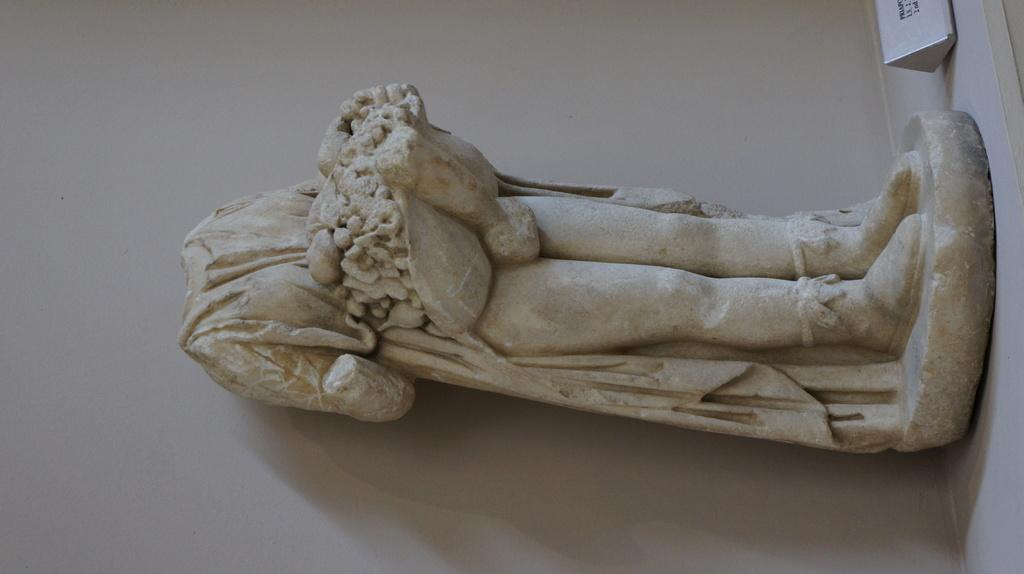What is the main subject of the image? There is a sculpture in the image. Where is the sculpture located in relation to other elements in the image? The sculpture is in front of a wall. What type of advice can be seen written on the sculpture in the image? There is no advice visible on the sculpture in the image. What material is the tin used for in the image? There is no tin present in the image. 